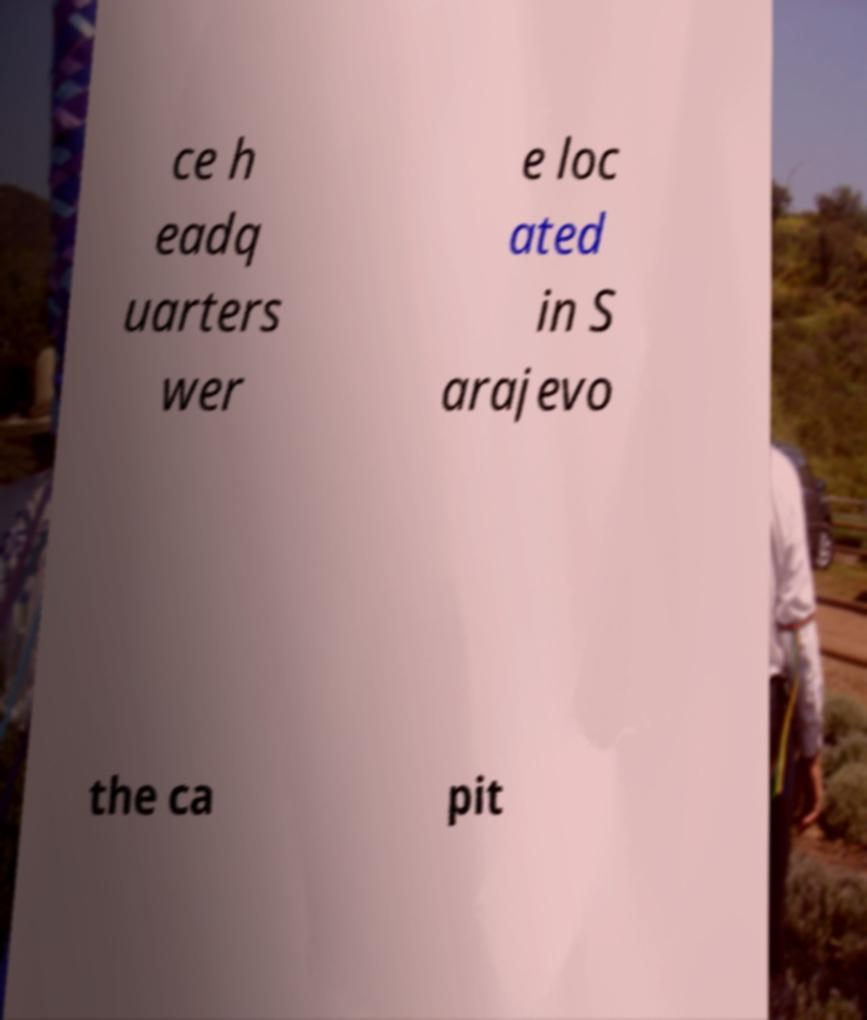Please read and relay the text visible in this image. What does it say? ce h eadq uarters wer e loc ated in S arajevo the ca pit 